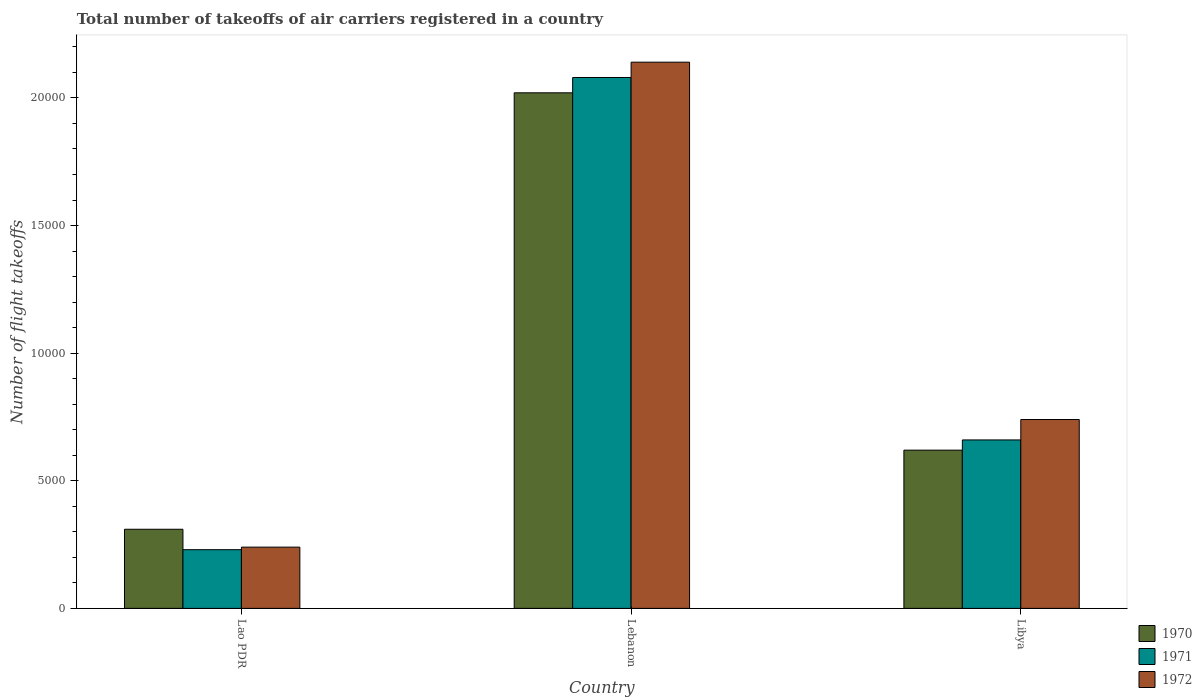How many different coloured bars are there?
Offer a very short reply. 3. How many groups of bars are there?
Make the answer very short. 3. Are the number of bars on each tick of the X-axis equal?
Keep it short and to the point. Yes. How many bars are there on the 2nd tick from the left?
Your answer should be very brief. 3. What is the label of the 2nd group of bars from the left?
Give a very brief answer. Lebanon. In how many cases, is the number of bars for a given country not equal to the number of legend labels?
Offer a terse response. 0. What is the total number of flight takeoffs in 1970 in Lao PDR?
Keep it short and to the point. 3100. Across all countries, what is the maximum total number of flight takeoffs in 1972?
Ensure brevity in your answer.  2.14e+04. Across all countries, what is the minimum total number of flight takeoffs in 1971?
Give a very brief answer. 2300. In which country was the total number of flight takeoffs in 1970 maximum?
Keep it short and to the point. Lebanon. In which country was the total number of flight takeoffs in 1971 minimum?
Offer a terse response. Lao PDR. What is the total total number of flight takeoffs in 1970 in the graph?
Offer a terse response. 2.95e+04. What is the difference between the total number of flight takeoffs in 1972 in Lebanon and that in Libya?
Give a very brief answer. 1.40e+04. What is the difference between the total number of flight takeoffs in 1970 in Lebanon and the total number of flight takeoffs in 1971 in Lao PDR?
Offer a very short reply. 1.79e+04. What is the average total number of flight takeoffs in 1971 per country?
Your answer should be very brief. 9900. What is the difference between the total number of flight takeoffs of/in 1970 and total number of flight takeoffs of/in 1971 in Lebanon?
Provide a short and direct response. -600. In how many countries, is the total number of flight takeoffs in 1970 greater than 20000?
Ensure brevity in your answer.  1. What is the ratio of the total number of flight takeoffs in 1970 in Lebanon to that in Libya?
Your answer should be compact. 3.26. Is the total number of flight takeoffs in 1971 in Lao PDR less than that in Libya?
Keep it short and to the point. Yes. Is the difference between the total number of flight takeoffs in 1970 in Lebanon and Libya greater than the difference between the total number of flight takeoffs in 1971 in Lebanon and Libya?
Your answer should be very brief. No. What is the difference between the highest and the second highest total number of flight takeoffs in 1972?
Keep it short and to the point. 1.40e+04. What is the difference between the highest and the lowest total number of flight takeoffs in 1971?
Offer a terse response. 1.85e+04. In how many countries, is the total number of flight takeoffs in 1971 greater than the average total number of flight takeoffs in 1971 taken over all countries?
Your answer should be compact. 1. What does the 3rd bar from the left in Lao PDR represents?
Offer a terse response. 1972. What does the 1st bar from the right in Lao PDR represents?
Offer a very short reply. 1972. Is it the case that in every country, the sum of the total number of flight takeoffs in 1971 and total number of flight takeoffs in 1970 is greater than the total number of flight takeoffs in 1972?
Offer a terse response. Yes. How many bars are there?
Your answer should be compact. 9. Does the graph contain any zero values?
Provide a short and direct response. No. Does the graph contain grids?
Offer a terse response. No. How many legend labels are there?
Provide a short and direct response. 3. How are the legend labels stacked?
Your response must be concise. Vertical. What is the title of the graph?
Your answer should be compact. Total number of takeoffs of air carriers registered in a country. What is the label or title of the Y-axis?
Your answer should be very brief. Number of flight takeoffs. What is the Number of flight takeoffs of 1970 in Lao PDR?
Your answer should be very brief. 3100. What is the Number of flight takeoffs of 1971 in Lao PDR?
Provide a succinct answer. 2300. What is the Number of flight takeoffs in 1972 in Lao PDR?
Make the answer very short. 2400. What is the Number of flight takeoffs of 1970 in Lebanon?
Offer a terse response. 2.02e+04. What is the Number of flight takeoffs of 1971 in Lebanon?
Keep it short and to the point. 2.08e+04. What is the Number of flight takeoffs of 1972 in Lebanon?
Provide a succinct answer. 2.14e+04. What is the Number of flight takeoffs of 1970 in Libya?
Provide a short and direct response. 6200. What is the Number of flight takeoffs in 1971 in Libya?
Your answer should be very brief. 6600. What is the Number of flight takeoffs in 1972 in Libya?
Your response must be concise. 7400. Across all countries, what is the maximum Number of flight takeoffs of 1970?
Your answer should be very brief. 2.02e+04. Across all countries, what is the maximum Number of flight takeoffs of 1971?
Your response must be concise. 2.08e+04. Across all countries, what is the maximum Number of flight takeoffs of 1972?
Provide a short and direct response. 2.14e+04. Across all countries, what is the minimum Number of flight takeoffs in 1970?
Your answer should be compact. 3100. Across all countries, what is the minimum Number of flight takeoffs of 1971?
Make the answer very short. 2300. Across all countries, what is the minimum Number of flight takeoffs in 1972?
Give a very brief answer. 2400. What is the total Number of flight takeoffs in 1970 in the graph?
Offer a very short reply. 2.95e+04. What is the total Number of flight takeoffs in 1971 in the graph?
Your answer should be compact. 2.97e+04. What is the total Number of flight takeoffs of 1972 in the graph?
Keep it short and to the point. 3.12e+04. What is the difference between the Number of flight takeoffs in 1970 in Lao PDR and that in Lebanon?
Keep it short and to the point. -1.71e+04. What is the difference between the Number of flight takeoffs of 1971 in Lao PDR and that in Lebanon?
Your answer should be compact. -1.85e+04. What is the difference between the Number of flight takeoffs in 1972 in Lao PDR and that in Lebanon?
Your answer should be compact. -1.90e+04. What is the difference between the Number of flight takeoffs of 1970 in Lao PDR and that in Libya?
Provide a short and direct response. -3100. What is the difference between the Number of flight takeoffs of 1971 in Lao PDR and that in Libya?
Provide a succinct answer. -4300. What is the difference between the Number of flight takeoffs of 1972 in Lao PDR and that in Libya?
Give a very brief answer. -5000. What is the difference between the Number of flight takeoffs of 1970 in Lebanon and that in Libya?
Provide a short and direct response. 1.40e+04. What is the difference between the Number of flight takeoffs of 1971 in Lebanon and that in Libya?
Offer a very short reply. 1.42e+04. What is the difference between the Number of flight takeoffs in 1972 in Lebanon and that in Libya?
Make the answer very short. 1.40e+04. What is the difference between the Number of flight takeoffs in 1970 in Lao PDR and the Number of flight takeoffs in 1971 in Lebanon?
Offer a very short reply. -1.77e+04. What is the difference between the Number of flight takeoffs of 1970 in Lao PDR and the Number of flight takeoffs of 1972 in Lebanon?
Offer a very short reply. -1.83e+04. What is the difference between the Number of flight takeoffs in 1971 in Lao PDR and the Number of flight takeoffs in 1972 in Lebanon?
Make the answer very short. -1.91e+04. What is the difference between the Number of flight takeoffs of 1970 in Lao PDR and the Number of flight takeoffs of 1971 in Libya?
Offer a very short reply. -3500. What is the difference between the Number of flight takeoffs of 1970 in Lao PDR and the Number of flight takeoffs of 1972 in Libya?
Offer a terse response. -4300. What is the difference between the Number of flight takeoffs of 1971 in Lao PDR and the Number of flight takeoffs of 1972 in Libya?
Ensure brevity in your answer.  -5100. What is the difference between the Number of flight takeoffs of 1970 in Lebanon and the Number of flight takeoffs of 1971 in Libya?
Make the answer very short. 1.36e+04. What is the difference between the Number of flight takeoffs of 1970 in Lebanon and the Number of flight takeoffs of 1972 in Libya?
Your answer should be very brief. 1.28e+04. What is the difference between the Number of flight takeoffs of 1971 in Lebanon and the Number of flight takeoffs of 1972 in Libya?
Make the answer very short. 1.34e+04. What is the average Number of flight takeoffs in 1970 per country?
Give a very brief answer. 9833.33. What is the average Number of flight takeoffs of 1971 per country?
Your answer should be very brief. 9900. What is the average Number of flight takeoffs of 1972 per country?
Provide a short and direct response. 1.04e+04. What is the difference between the Number of flight takeoffs in 1970 and Number of flight takeoffs in 1971 in Lao PDR?
Make the answer very short. 800. What is the difference between the Number of flight takeoffs of 1970 and Number of flight takeoffs of 1972 in Lao PDR?
Ensure brevity in your answer.  700. What is the difference between the Number of flight takeoffs in 1971 and Number of flight takeoffs in 1972 in Lao PDR?
Your response must be concise. -100. What is the difference between the Number of flight takeoffs of 1970 and Number of flight takeoffs of 1971 in Lebanon?
Make the answer very short. -600. What is the difference between the Number of flight takeoffs of 1970 and Number of flight takeoffs of 1972 in Lebanon?
Give a very brief answer. -1200. What is the difference between the Number of flight takeoffs in 1971 and Number of flight takeoffs in 1972 in Lebanon?
Give a very brief answer. -600. What is the difference between the Number of flight takeoffs of 1970 and Number of flight takeoffs of 1971 in Libya?
Keep it short and to the point. -400. What is the difference between the Number of flight takeoffs of 1970 and Number of flight takeoffs of 1972 in Libya?
Your answer should be compact. -1200. What is the difference between the Number of flight takeoffs in 1971 and Number of flight takeoffs in 1972 in Libya?
Offer a very short reply. -800. What is the ratio of the Number of flight takeoffs of 1970 in Lao PDR to that in Lebanon?
Your answer should be compact. 0.15. What is the ratio of the Number of flight takeoffs in 1971 in Lao PDR to that in Lebanon?
Make the answer very short. 0.11. What is the ratio of the Number of flight takeoffs of 1972 in Lao PDR to that in Lebanon?
Your answer should be compact. 0.11. What is the ratio of the Number of flight takeoffs of 1971 in Lao PDR to that in Libya?
Ensure brevity in your answer.  0.35. What is the ratio of the Number of flight takeoffs of 1972 in Lao PDR to that in Libya?
Make the answer very short. 0.32. What is the ratio of the Number of flight takeoffs of 1970 in Lebanon to that in Libya?
Offer a very short reply. 3.26. What is the ratio of the Number of flight takeoffs of 1971 in Lebanon to that in Libya?
Provide a short and direct response. 3.15. What is the ratio of the Number of flight takeoffs in 1972 in Lebanon to that in Libya?
Your response must be concise. 2.89. What is the difference between the highest and the second highest Number of flight takeoffs in 1970?
Offer a very short reply. 1.40e+04. What is the difference between the highest and the second highest Number of flight takeoffs in 1971?
Your answer should be compact. 1.42e+04. What is the difference between the highest and the second highest Number of flight takeoffs in 1972?
Offer a terse response. 1.40e+04. What is the difference between the highest and the lowest Number of flight takeoffs in 1970?
Your answer should be very brief. 1.71e+04. What is the difference between the highest and the lowest Number of flight takeoffs in 1971?
Keep it short and to the point. 1.85e+04. What is the difference between the highest and the lowest Number of flight takeoffs in 1972?
Offer a very short reply. 1.90e+04. 